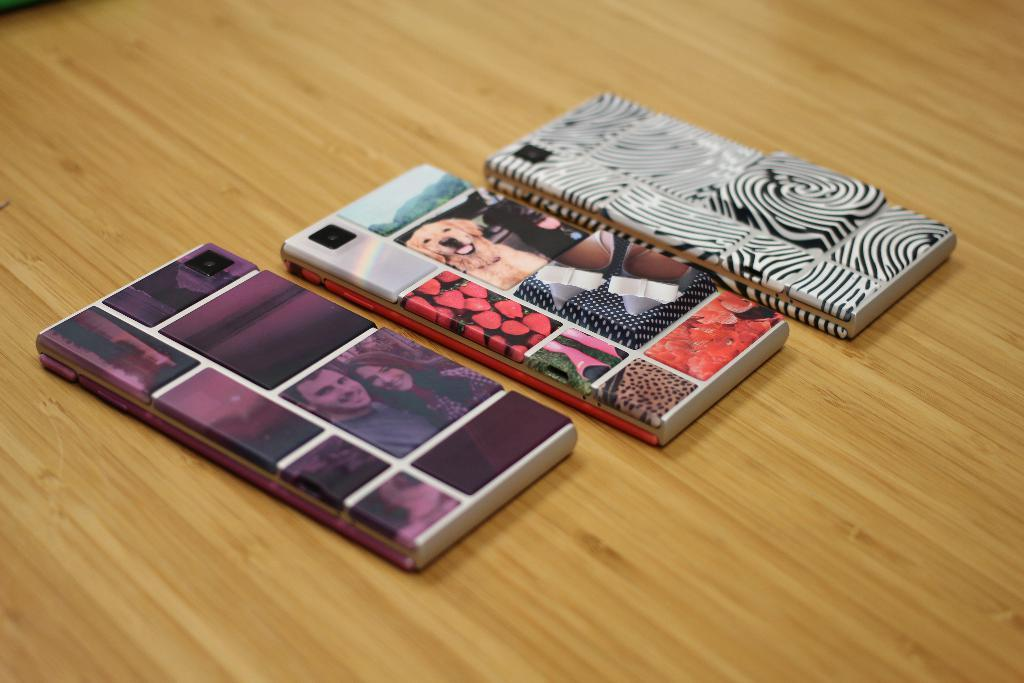What objects are present in the image? There are mobiles in the image. Where are the mobiles located? The mobiles are placed on a table. What type of engine can be seen powering the mobiles in the image? There is no mention of an engine or approval in the image. The mobiles are simply placed on a table. 